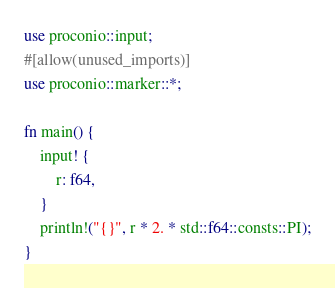<code> <loc_0><loc_0><loc_500><loc_500><_Rust_>use proconio::input;
#[allow(unused_imports)]
use proconio::marker::*;

fn main() {
    input! {
        r: f64,
    }
    println!("{}", r * 2. * std::f64::consts::PI);
}
</code> 